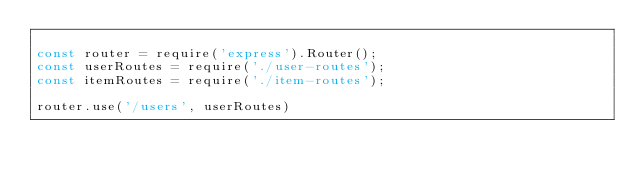Convert code to text. <code><loc_0><loc_0><loc_500><loc_500><_JavaScript_>
const router = require('express').Router();
const userRoutes = require('./user-routes');
const itemRoutes = require('./item-routes');

router.use('/users', userRoutes)</code> 